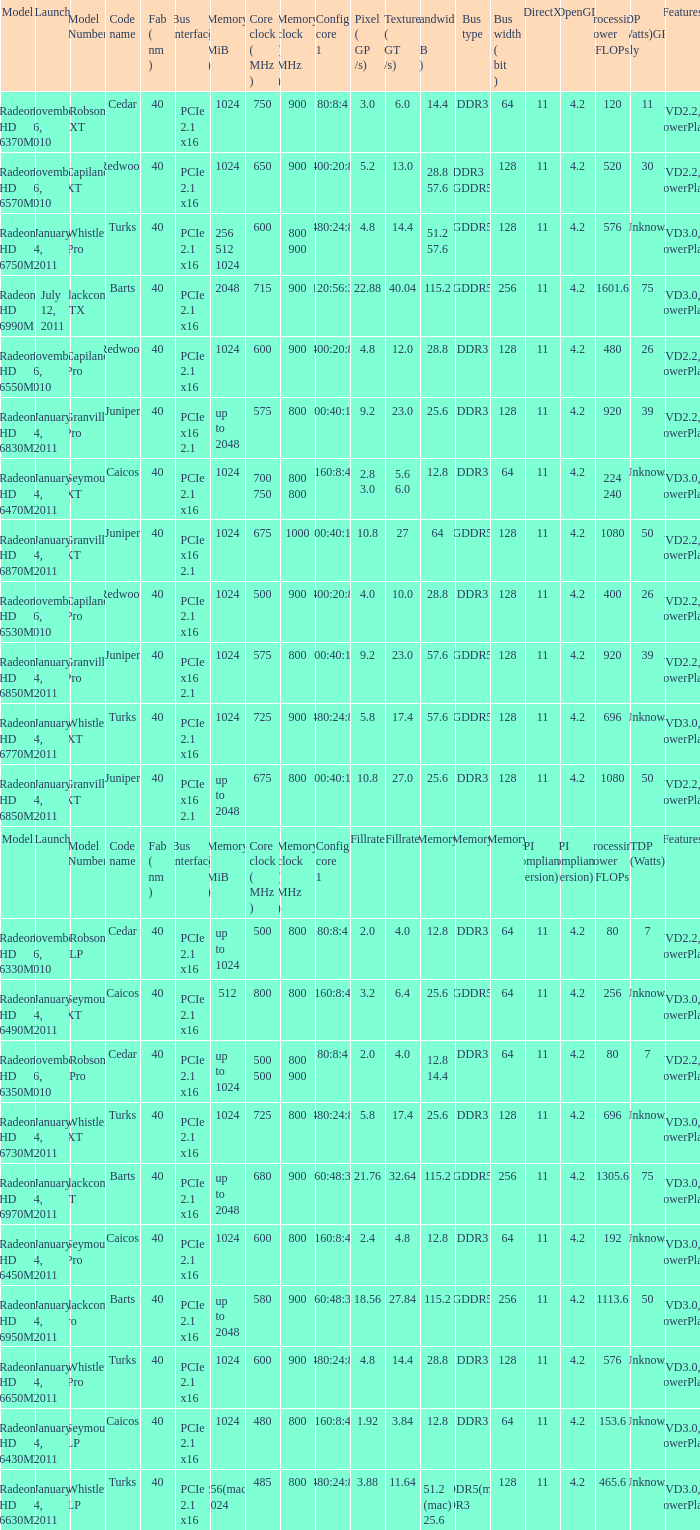How many values for fab(nm) if the model number is Whistler LP? 1.0. 